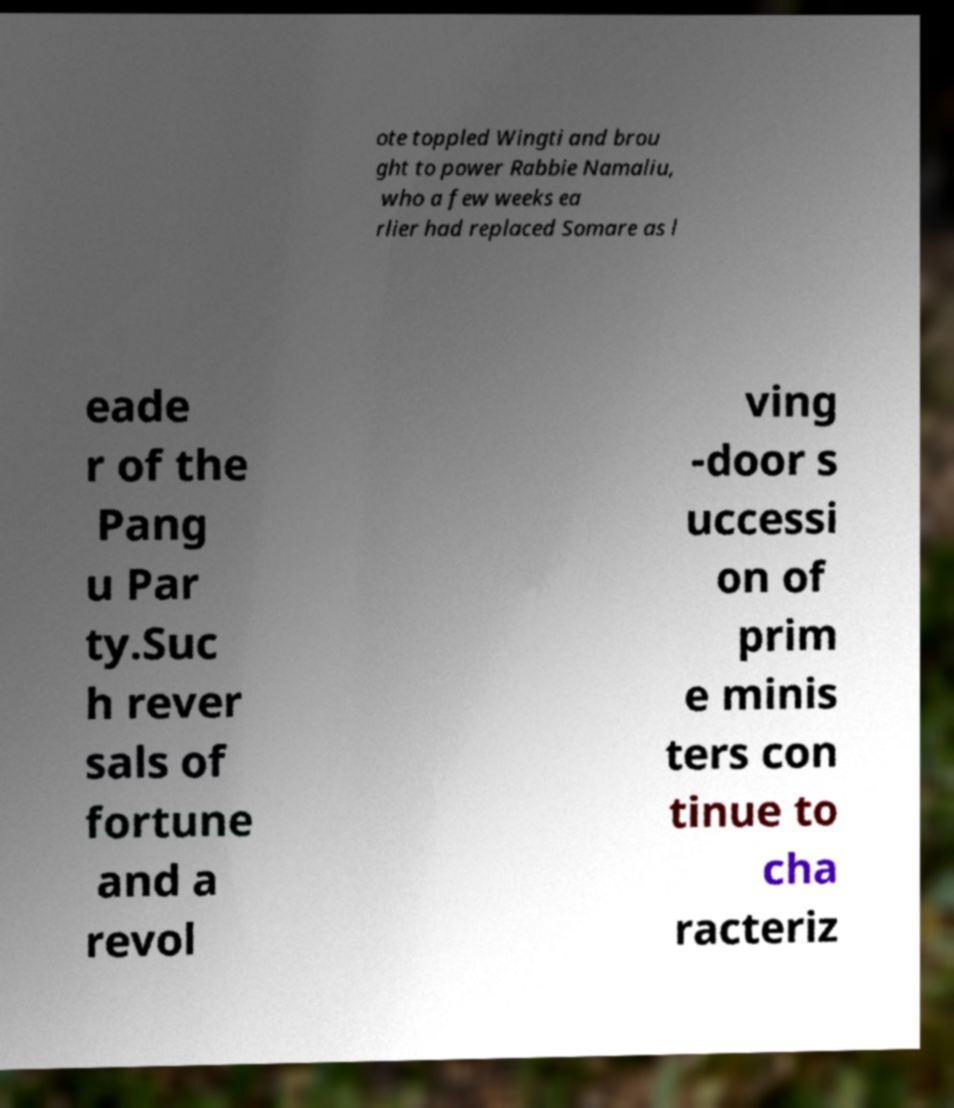Can you accurately transcribe the text from the provided image for me? ote toppled Wingti and brou ght to power Rabbie Namaliu, who a few weeks ea rlier had replaced Somare as l eade r of the Pang u Par ty.Suc h rever sals of fortune and a revol ving -door s uccessi on of prim e minis ters con tinue to cha racteriz 